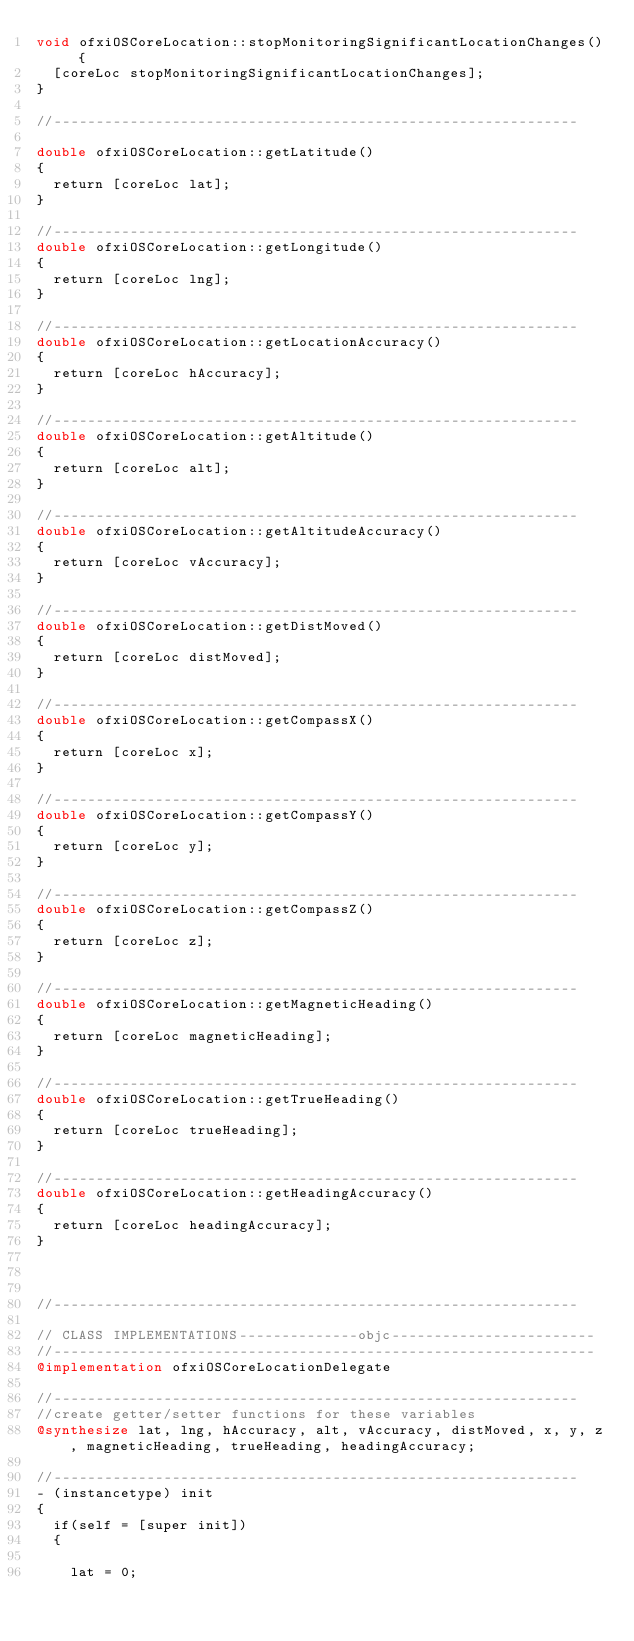<code> <loc_0><loc_0><loc_500><loc_500><_ObjectiveC_>void ofxiOSCoreLocation::stopMonitoringSignificantLocationChanges() {
  [coreLoc stopMonitoringSignificantLocationChanges];
}

//--------------------------------------------------------------

double ofxiOSCoreLocation::getLatitude()
{
	return [coreLoc lat];
}

//--------------------------------------------------------------
double ofxiOSCoreLocation::getLongitude()
{
	return [coreLoc lng];
}

//--------------------------------------------------------------
double ofxiOSCoreLocation::getLocationAccuracy()
{
	return [coreLoc hAccuracy];
}

//--------------------------------------------------------------
double ofxiOSCoreLocation::getAltitude()
{
	return [coreLoc alt];
}

//--------------------------------------------------------------
double ofxiOSCoreLocation::getAltitudeAccuracy()
{
	return [coreLoc vAccuracy];
}

//--------------------------------------------------------------
double ofxiOSCoreLocation::getDistMoved()
{
	return [coreLoc distMoved];
}

//--------------------------------------------------------------
double ofxiOSCoreLocation::getCompassX()
{
	return [coreLoc x];
}

//--------------------------------------------------------------
double ofxiOSCoreLocation::getCompassY()
{
	return [coreLoc y];
}

//--------------------------------------------------------------
double ofxiOSCoreLocation::getCompassZ()
{
	return [coreLoc z];
}

//--------------------------------------------------------------
double ofxiOSCoreLocation::getMagneticHeading()
{
	return [coreLoc magneticHeading];
}

//--------------------------------------------------------------
double ofxiOSCoreLocation::getTrueHeading()
{
	return [coreLoc trueHeading];
}

//--------------------------------------------------------------
double ofxiOSCoreLocation::getHeadingAccuracy()
{
	return [coreLoc headingAccuracy];
}



//--------------------------------------------------------------

// CLASS IMPLEMENTATIONS--------------objc------------------------
//----------------------------------------------------------------
@implementation ofxiOSCoreLocationDelegate

//--------------------------------------------------------------
//create getter/setter functions for these variables
@synthesize lat, lng, hAccuracy, alt, vAccuracy, distMoved, x, y, z, magneticHeading, trueHeading, headingAccuracy;

//--------------------------------------------------------------
- (instancetype) init
{
	if(self = [super init])
	{		
		
		lat = 0;</code> 